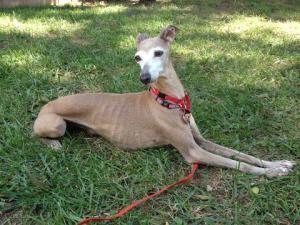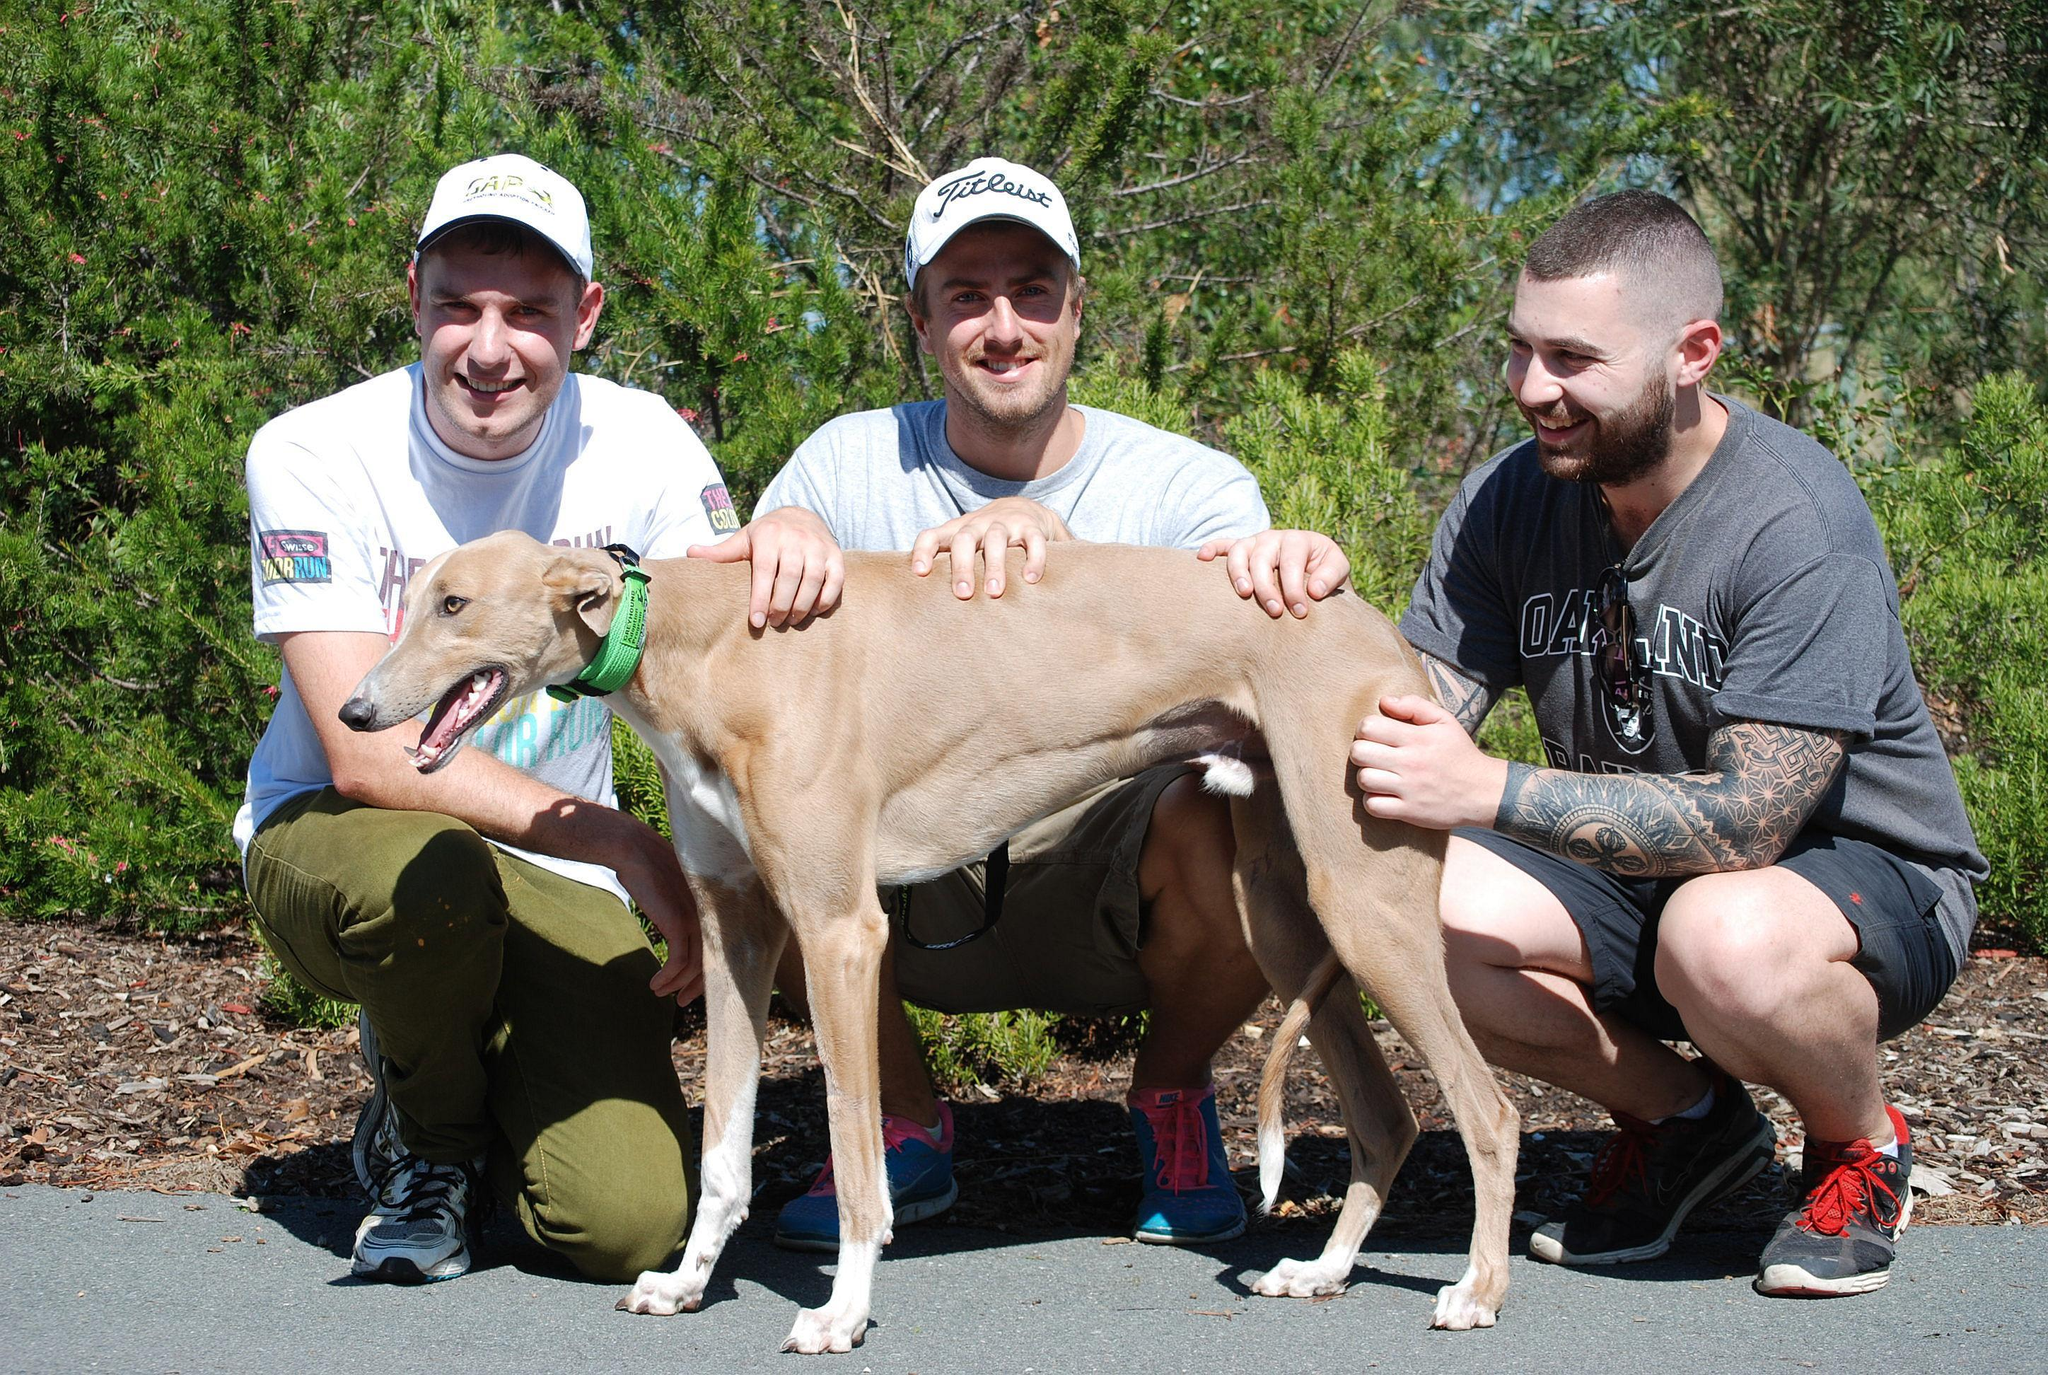The first image is the image on the left, the second image is the image on the right. For the images displayed, is the sentence "There are at least three mammals in total." factually correct? Answer yes or no. Yes. The first image is the image on the left, the second image is the image on the right. Evaluate the accuracy of this statement regarding the images: "The combined images include two dogs in motion, and no images show a human with a dog.". Is it true? Answer yes or no. No. 